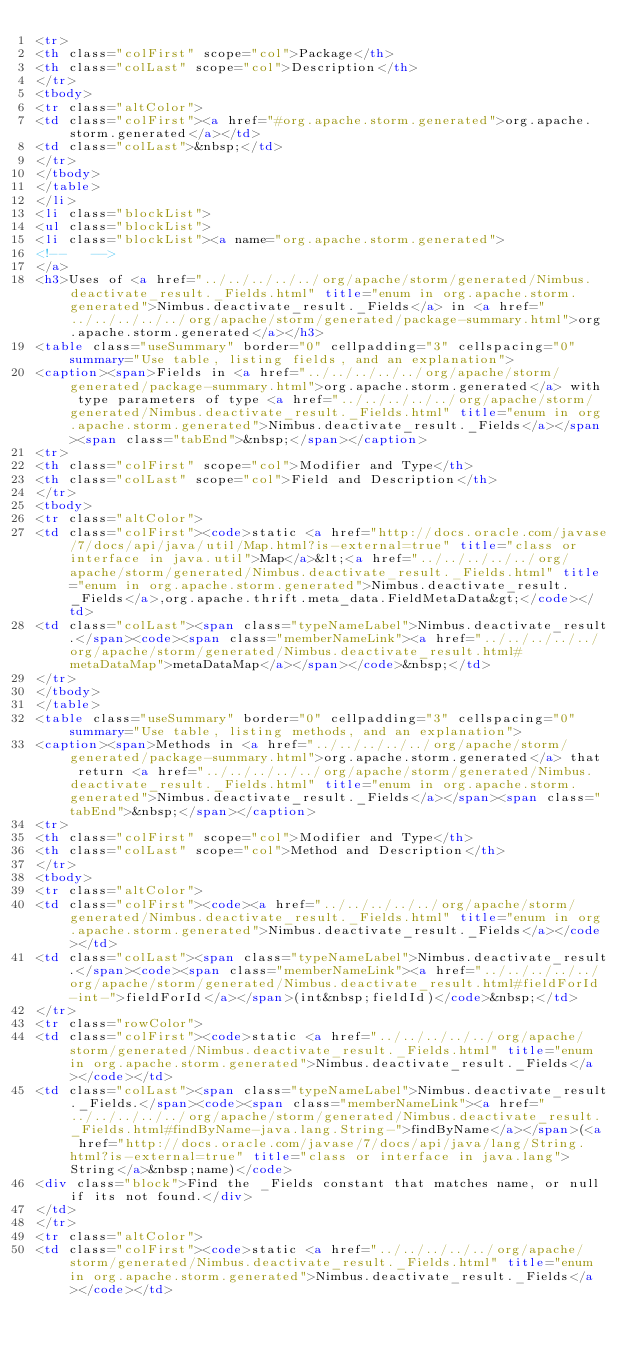<code> <loc_0><loc_0><loc_500><loc_500><_HTML_><tr>
<th class="colFirst" scope="col">Package</th>
<th class="colLast" scope="col">Description</th>
</tr>
<tbody>
<tr class="altColor">
<td class="colFirst"><a href="#org.apache.storm.generated">org.apache.storm.generated</a></td>
<td class="colLast">&nbsp;</td>
</tr>
</tbody>
</table>
</li>
<li class="blockList">
<ul class="blockList">
<li class="blockList"><a name="org.apache.storm.generated">
<!--   -->
</a>
<h3>Uses of <a href="../../../../../org/apache/storm/generated/Nimbus.deactivate_result._Fields.html" title="enum in org.apache.storm.generated">Nimbus.deactivate_result._Fields</a> in <a href="../../../../../org/apache/storm/generated/package-summary.html">org.apache.storm.generated</a></h3>
<table class="useSummary" border="0" cellpadding="3" cellspacing="0" summary="Use table, listing fields, and an explanation">
<caption><span>Fields in <a href="../../../../../org/apache/storm/generated/package-summary.html">org.apache.storm.generated</a> with type parameters of type <a href="../../../../../org/apache/storm/generated/Nimbus.deactivate_result._Fields.html" title="enum in org.apache.storm.generated">Nimbus.deactivate_result._Fields</a></span><span class="tabEnd">&nbsp;</span></caption>
<tr>
<th class="colFirst" scope="col">Modifier and Type</th>
<th class="colLast" scope="col">Field and Description</th>
</tr>
<tbody>
<tr class="altColor">
<td class="colFirst"><code>static <a href="http://docs.oracle.com/javase/7/docs/api/java/util/Map.html?is-external=true" title="class or interface in java.util">Map</a>&lt;<a href="../../../../../org/apache/storm/generated/Nimbus.deactivate_result._Fields.html" title="enum in org.apache.storm.generated">Nimbus.deactivate_result._Fields</a>,org.apache.thrift.meta_data.FieldMetaData&gt;</code></td>
<td class="colLast"><span class="typeNameLabel">Nimbus.deactivate_result.</span><code><span class="memberNameLink"><a href="../../../../../org/apache/storm/generated/Nimbus.deactivate_result.html#metaDataMap">metaDataMap</a></span></code>&nbsp;</td>
</tr>
</tbody>
</table>
<table class="useSummary" border="0" cellpadding="3" cellspacing="0" summary="Use table, listing methods, and an explanation">
<caption><span>Methods in <a href="../../../../../org/apache/storm/generated/package-summary.html">org.apache.storm.generated</a> that return <a href="../../../../../org/apache/storm/generated/Nimbus.deactivate_result._Fields.html" title="enum in org.apache.storm.generated">Nimbus.deactivate_result._Fields</a></span><span class="tabEnd">&nbsp;</span></caption>
<tr>
<th class="colFirst" scope="col">Modifier and Type</th>
<th class="colLast" scope="col">Method and Description</th>
</tr>
<tbody>
<tr class="altColor">
<td class="colFirst"><code><a href="../../../../../org/apache/storm/generated/Nimbus.deactivate_result._Fields.html" title="enum in org.apache.storm.generated">Nimbus.deactivate_result._Fields</a></code></td>
<td class="colLast"><span class="typeNameLabel">Nimbus.deactivate_result.</span><code><span class="memberNameLink"><a href="../../../../../org/apache/storm/generated/Nimbus.deactivate_result.html#fieldForId-int-">fieldForId</a></span>(int&nbsp;fieldId)</code>&nbsp;</td>
</tr>
<tr class="rowColor">
<td class="colFirst"><code>static <a href="../../../../../org/apache/storm/generated/Nimbus.deactivate_result._Fields.html" title="enum in org.apache.storm.generated">Nimbus.deactivate_result._Fields</a></code></td>
<td class="colLast"><span class="typeNameLabel">Nimbus.deactivate_result._Fields.</span><code><span class="memberNameLink"><a href="../../../../../org/apache/storm/generated/Nimbus.deactivate_result._Fields.html#findByName-java.lang.String-">findByName</a></span>(<a href="http://docs.oracle.com/javase/7/docs/api/java/lang/String.html?is-external=true" title="class or interface in java.lang">String</a>&nbsp;name)</code>
<div class="block">Find the _Fields constant that matches name, or null if its not found.</div>
</td>
</tr>
<tr class="altColor">
<td class="colFirst"><code>static <a href="../../../../../org/apache/storm/generated/Nimbus.deactivate_result._Fields.html" title="enum in org.apache.storm.generated">Nimbus.deactivate_result._Fields</a></code></td></code> 